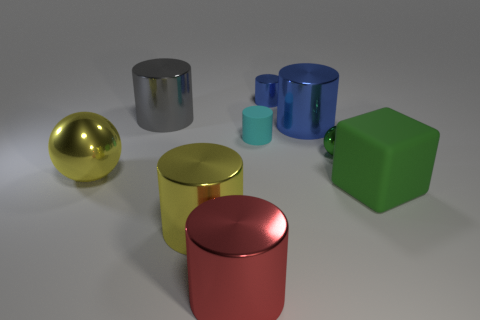Subtract all gray cylinders. How many cylinders are left? 5 Subtract all big gray shiny cylinders. How many cylinders are left? 5 Subtract all cyan cylinders. Subtract all blue blocks. How many cylinders are left? 5 Subtract all cubes. How many objects are left? 8 Subtract 0 blue blocks. How many objects are left? 9 Subtract all small rubber cylinders. Subtract all yellow metallic cylinders. How many objects are left? 7 Add 2 large blocks. How many large blocks are left? 3 Add 3 large rubber things. How many large rubber things exist? 4 